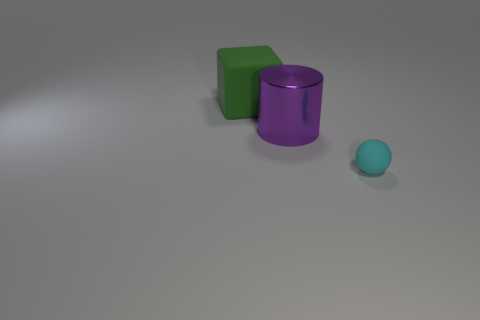Does the big thing in front of the large green thing have the same material as the green thing on the left side of the big purple metallic thing?
Provide a short and direct response. No. The object that is in front of the large green object and behind the tiny cyan object has what shape?
Your answer should be very brief. Cylinder. There is a big object that is in front of the object behind the purple thing; what is its material?
Make the answer very short. Metal. Is the number of purple cylinders greater than the number of small brown things?
Your answer should be compact. Yes. Do the metal object and the large cube have the same color?
Make the answer very short. No. There is a purple thing that is the same size as the green rubber block; what is it made of?
Offer a very short reply. Metal. Are the purple thing and the tiny ball made of the same material?
Your response must be concise. No. What number of cyan objects are made of the same material as the big cylinder?
Give a very brief answer. 0. How many objects are things that are behind the tiny cyan object or things that are behind the purple shiny thing?
Make the answer very short. 2. Is the number of small rubber things in front of the tiny cyan rubber thing greater than the number of large shiny cylinders in front of the large purple thing?
Your answer should be very brief. No. 